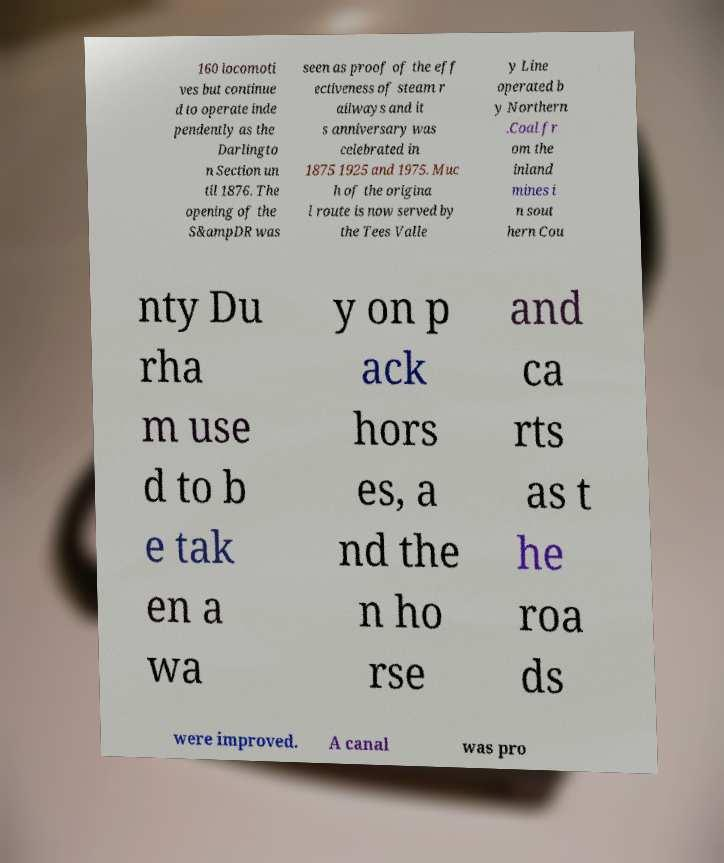Could you assist in decoding the text presented in this image and type it out clearly? 160 locomoti ves but continue d to operate inde pendently as the Darlingto n Section un til 1876. The opening of the S&ampDR was seen as proof of the eff ectiveness of steam r ailways and it s anniversary was celebrated in 1875 1925 and 1975. Muc h of the origina l route is now served by the Tees Valle y Line operated b y Northern .Coal fr om the inland mines i n sout hern Cou nty Du rha m use d to b e tak en a wa y on p ack hors es, a nd the n ho rse and ca rts as t he roa ds were improved. A canal was pro 